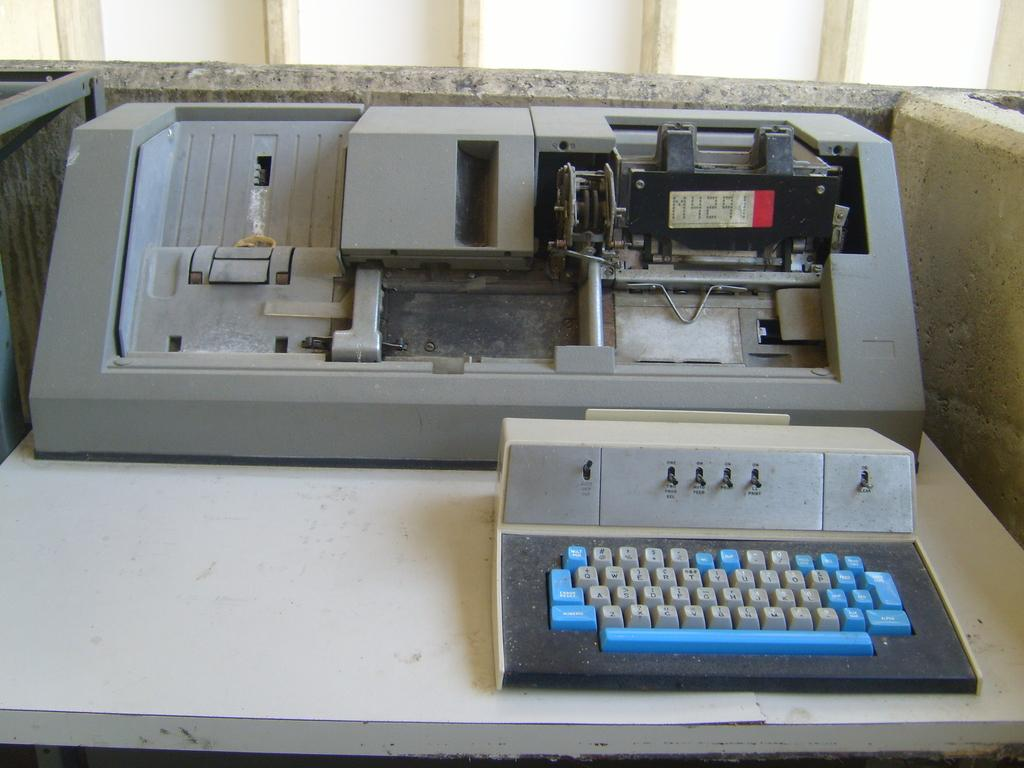<image>
Create a compact narrative representing the image presented. An old partially disassembled printer with the code M4291 showing on its display. 